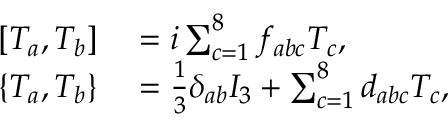Convert formula to latex. <formula><loc_0><loc_0><loc_500><loc_500>\begin{array} { r l } { \left [ T _ { a } , T _ { b } \right ] } & = i \sum _ { c = 1 } ^ { 8 } f _ { a b c } T _ { c } , } \\ { \left \{ T _ { a } , T _ { b } \right \} } & = { \frac { 1 } { 3 } } \delta _ { a b } I _ { 3 } + \sum _ { c = 1 } ^ { 8 } d _ { a b c } T _ { c } , } \end{array}</formula> 